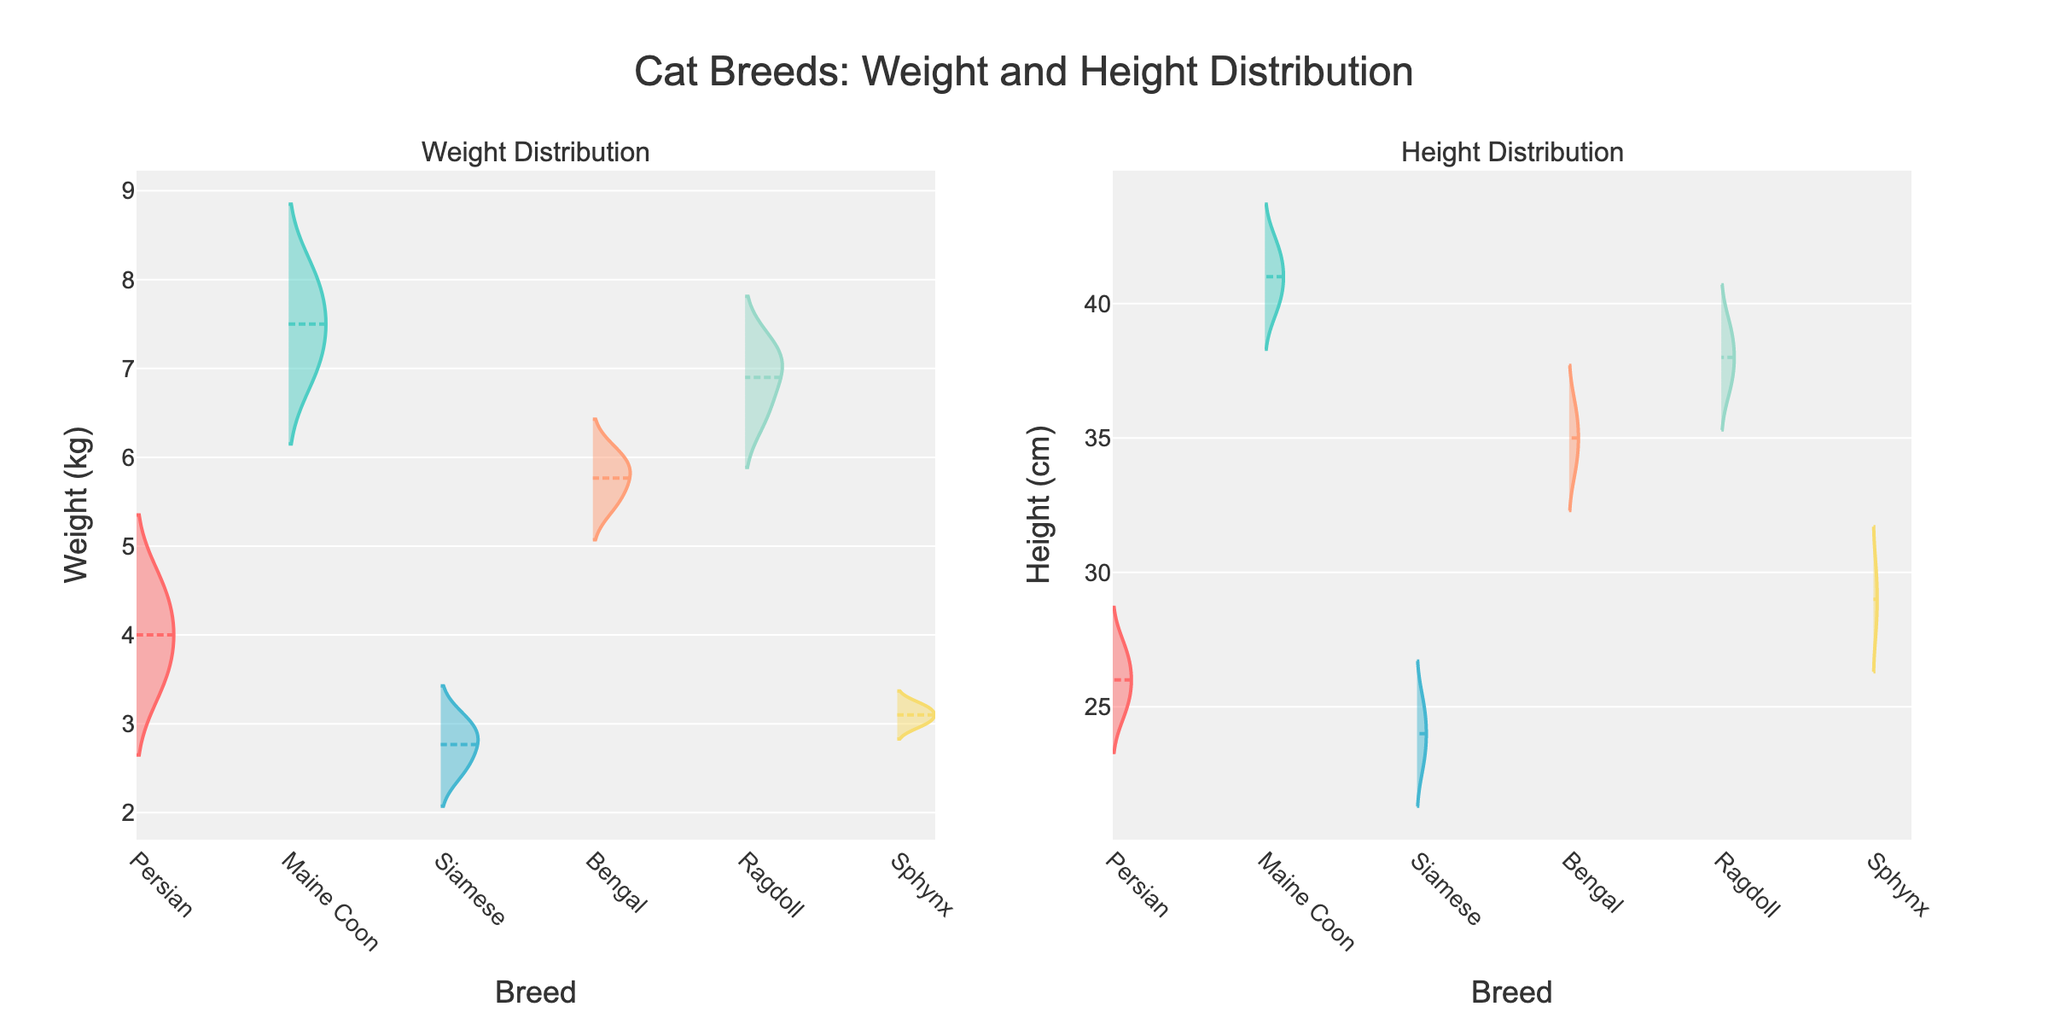What's the title of the figure? The title is typically prominently displayed at the top of the figure.
Answer: Cat Breeds: Weight and Height Distribution Which breed appears to have the highest average weight distribution? By observing the violin plots, the breed with the longest distribution towards higher values represents the highest weight.
Answer: Maine Coon What is the range of heights for the Bengal breed? By examining the Bengal breed's violin plot in the Height Distribution subplot, note the lowest and highest points of the distribution.
Answer: 34 cm to 36 cm How does the average height of the Ragdoll compare to that of the Sphynx? Compare the mean line visible in the violin plots for Ragdoll and Sphynx in the Height Distribution subplot to determine which is higher.
Answer: Ragdoll is higher Which breed has the smallest range in weight distribution? Identify the breed whose weight distribution is the shortest in the Weight Distribution subplot.
Answer: Siamese Which breed shows a broader distribution in height, Bengal or Ragdoll? Compare the range of the height distribution of both the Bengal and Ragdoll in the Height Distribution subplot.
Answer: Ragdoll What is the average weight of the Persian breed? For the Persian breed in the Weight Distribution subplot, locate the mean line and read the corresponding value.
Answer: Approximately 4 kg Considering the weight distributions, which breed shows the greatest variability? Look at the width and spread of the violin plots in the Weight Distribution subplot; a broader plot indicates greater variability.
Answer: Maine Coon Is there a noticeable difference in the height distributions between Persian and Ragdoll breeds? Compare the violin plots for Persian and Ragdoll in the Height Distribution subplot to see if their shapes and ranges differ significantly.
Answer: Yes, Ragdoll is noticeably taller 